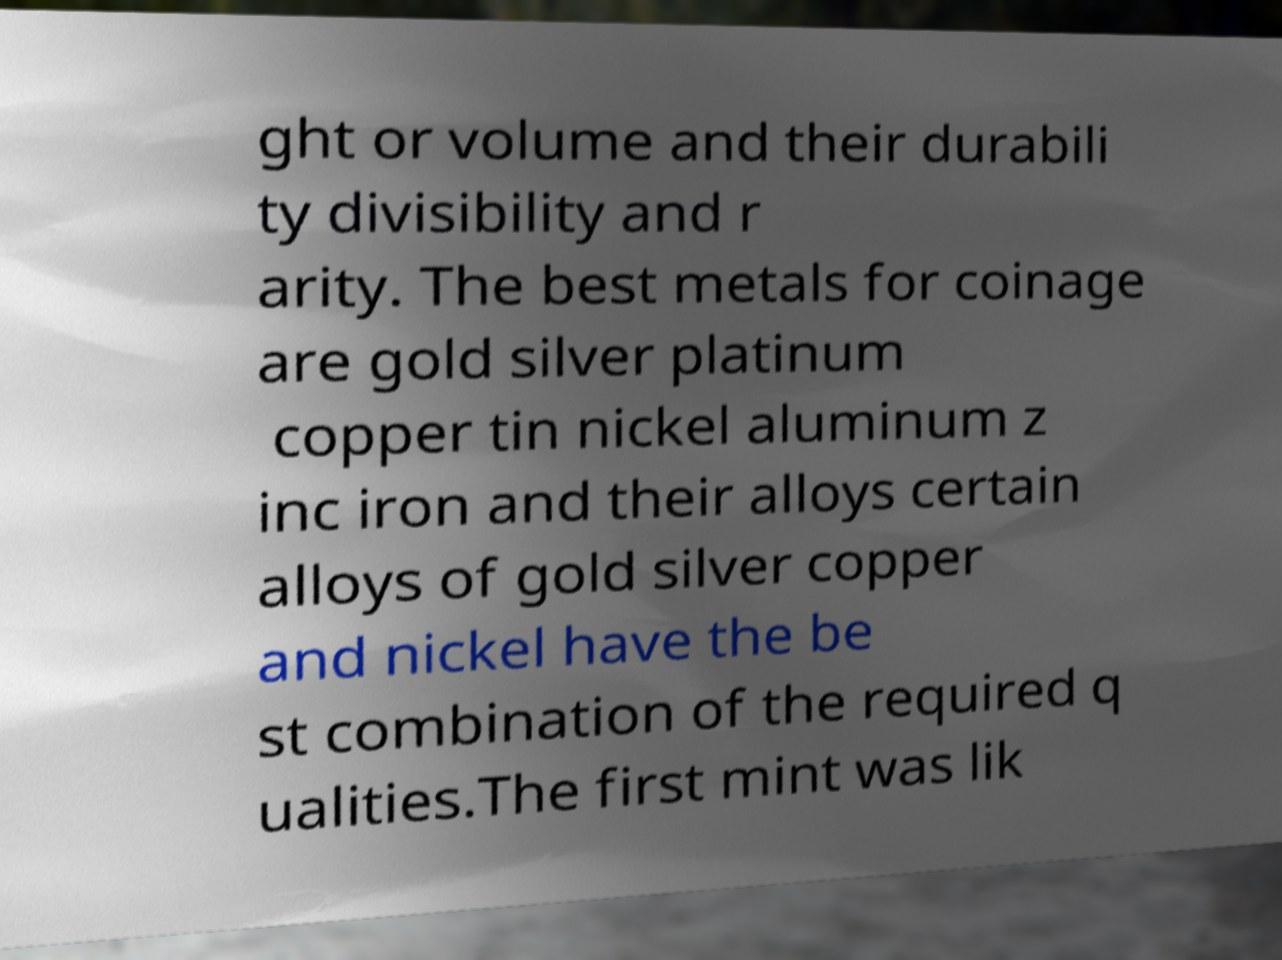I need the written content from this picture converted into text. Can you do that? ght or volume and their durabili ty divisibility and r arity. The best metals for coinage are gold silver platinum copper tin nickel aluminum z inc iron and their alloys certain alloys of gold silver copper and nickel have the be st combination of the required q ualities.The first mint was lik 